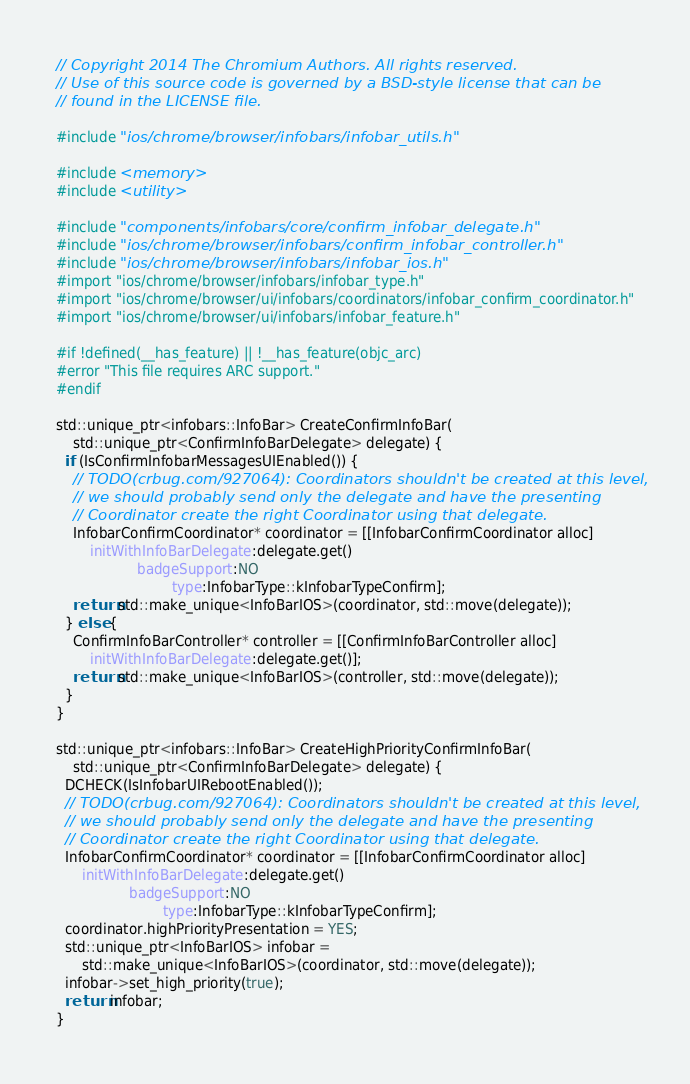<code> <loc_0><loc_0><loc_500><loc_500><_ObjectiveC_>// Copyright 2014 The Chromium Authors. All rights reserved.
// Use of this source code is governed by a BSD-style license that can be
// found in the LICENSE file.

#include "ios/chrome/browser/infobars/infobar_utils.h"

#include <memory>
#include <utility>

#include "components/infobars/core/confirm_infobar_delegate.h"
#include "ios/chrome/browser/infobars/confirm_infobar_controller.h"
#include "ios/chrome/browser/infobars/infobar_ios.h"
#import "ios/chrome/browser/infobars/infobar_type.h"
#import "ios/chrome/browser/ui/infobars/coordinators/infobar_confirm_coordinator.h"
#import "ios/chrome/browser/ui/infobars/infobar_feature.h"

#if !defined(__has_feature) || !__has_feature(objc_arc)
#error "This file requires ARC support."
#endif

std::unique_ptr<infobars::InfoBar> CreateConfirmInfoBar(
    std::unique_ptr<ConfirmInfoBarDelegate> delegate) {
  if (IsConfirmInfobarMessagesUIEnabled()) {
    // TODO(crbug.com/927064): Coordinators shouldn't be created at this level,
    // we should probably send only the delegate and have the presenting
    // Coordinator create the right Coordinator using that delegate.
    InfobarConfirmCoordinator* coordinator = [[InfobarConfirmCoordinator alloc]
        initWithInfoBarDelegate:delegate.get()
                   badgeSupport:NO
                           type:InfobarType::kInfobarTypeConfirm];
    return std::make_unique<InfoBarIOS>(coordinator, std::move(delegate));
  } else {
    ConfirmInfoBarController* controller = [[ConfirmInfoBarController alloc]
        initWithInfoBarDelegate:delegate.get()];
    return std::make_unique<InfoBarIOS>(controller, std::move(delegate));
  }
}

std::unique_ptr<infobars::InfoBar> CreateHighPriorityConfirmInfoBar(
    std::unique_ptr<ConfirmInfoBarDelegate> delegate) {
  DCHECK(IsInfobarUIRebootEnabled());
  // TODO(crbug.com/927064): Coordinators shouldn't be created at this level,
  // we should probably send only the delegate and have the presenting
  // Coordinator create the right Coordinator using that delegate.
  InfobarConfirmCoordinator* coordinator = [[InfobarConfirmCoordinator alloc]
      initWithInfoBarDelegate:delegate.get()
                 badgeSupport:NO
                         type:InfobarType::kInfobarTypeConfirm];
  coordinator.highPriorityPresentation = YES;
  std::unique_ptr<InfoBarIOS> infobar =
      std::make_unique<InfoBarIOS>(coordinator, std::move(delegate));
  infobar->set_high_priority(true);
  return infobar;
}
</code> 